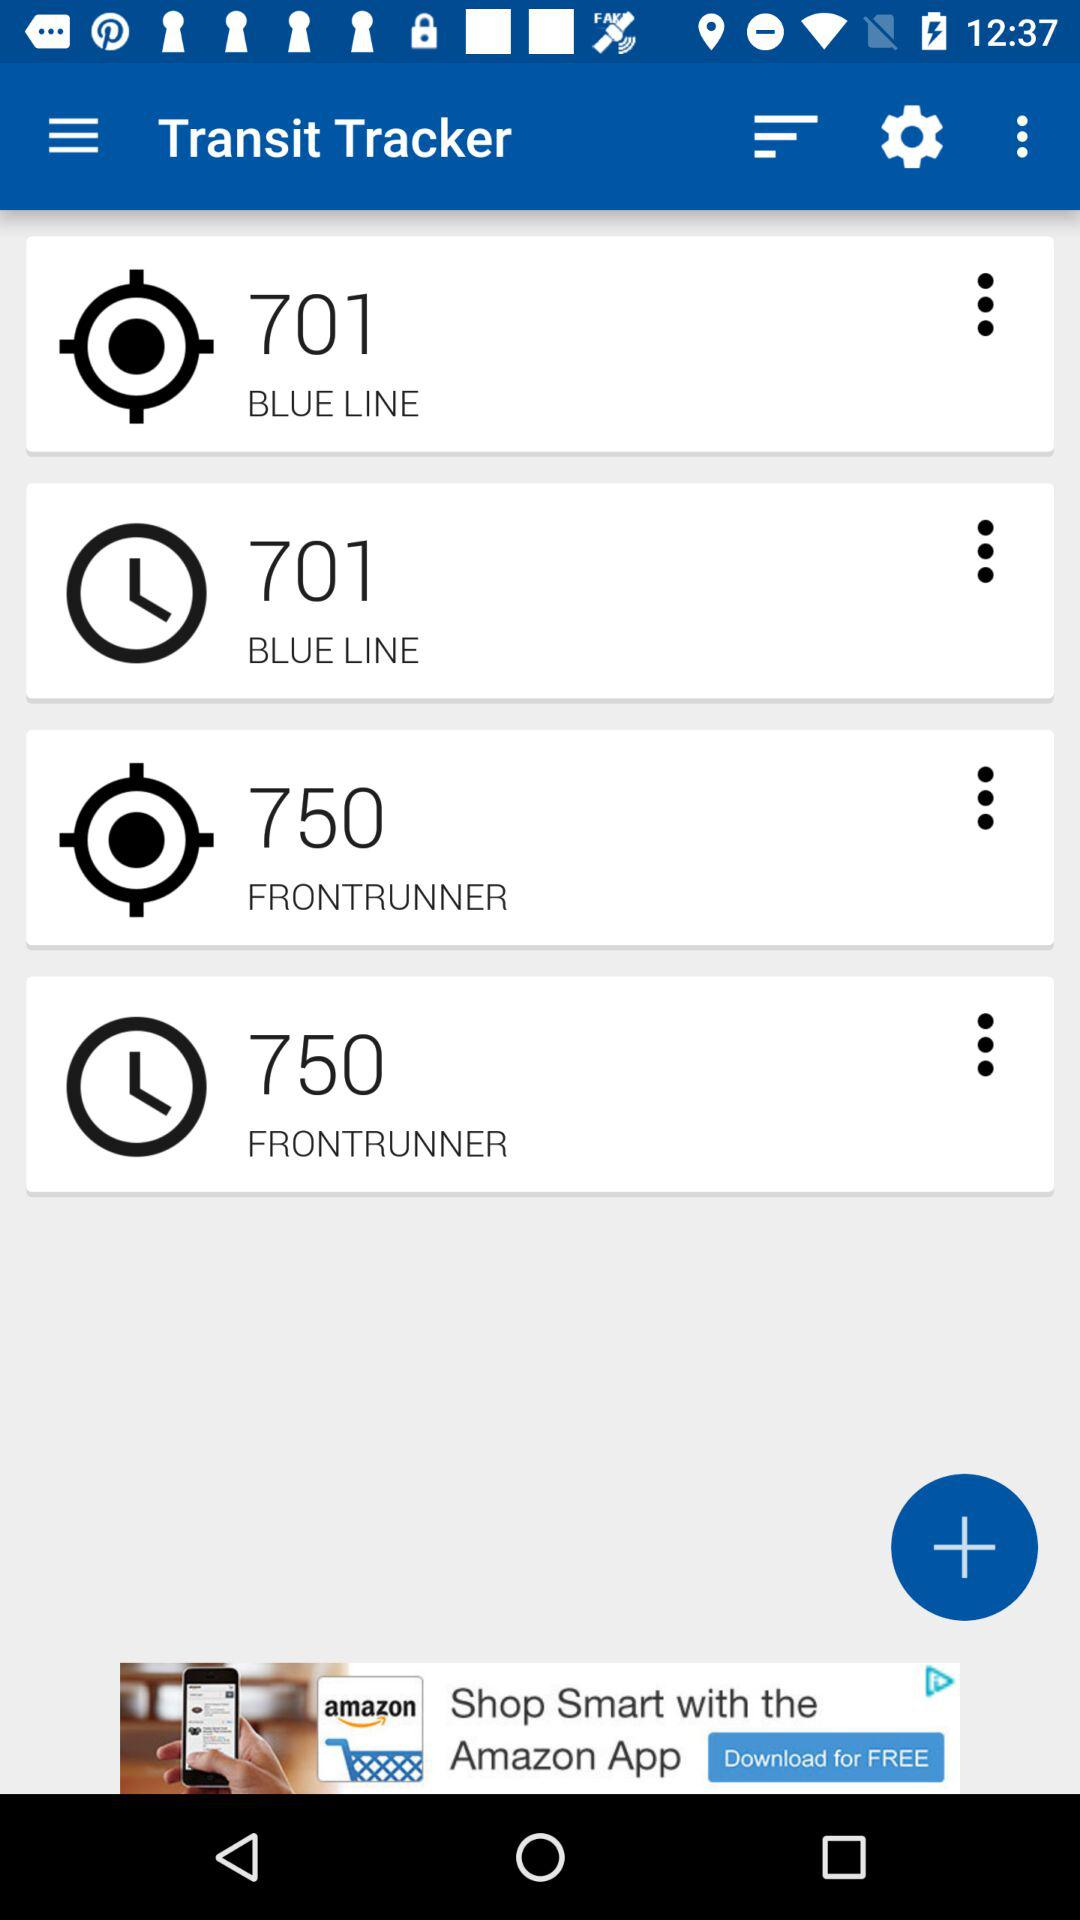What is the value of time for the frontrunner?
When the provided information is insufficient, respond with <no answer>. <no answer> 